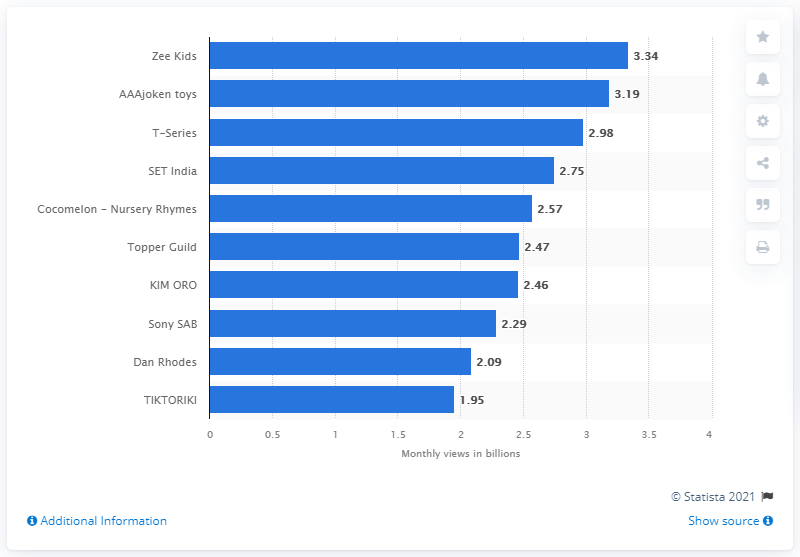List a handful of essential elements in this visual. Zee Kids has been ranked first with 3.34 billion channel views, making it the most viewed YouTube channel. According to the statistics, AAAjoken toys were ranked second with 3.19 billion views. 